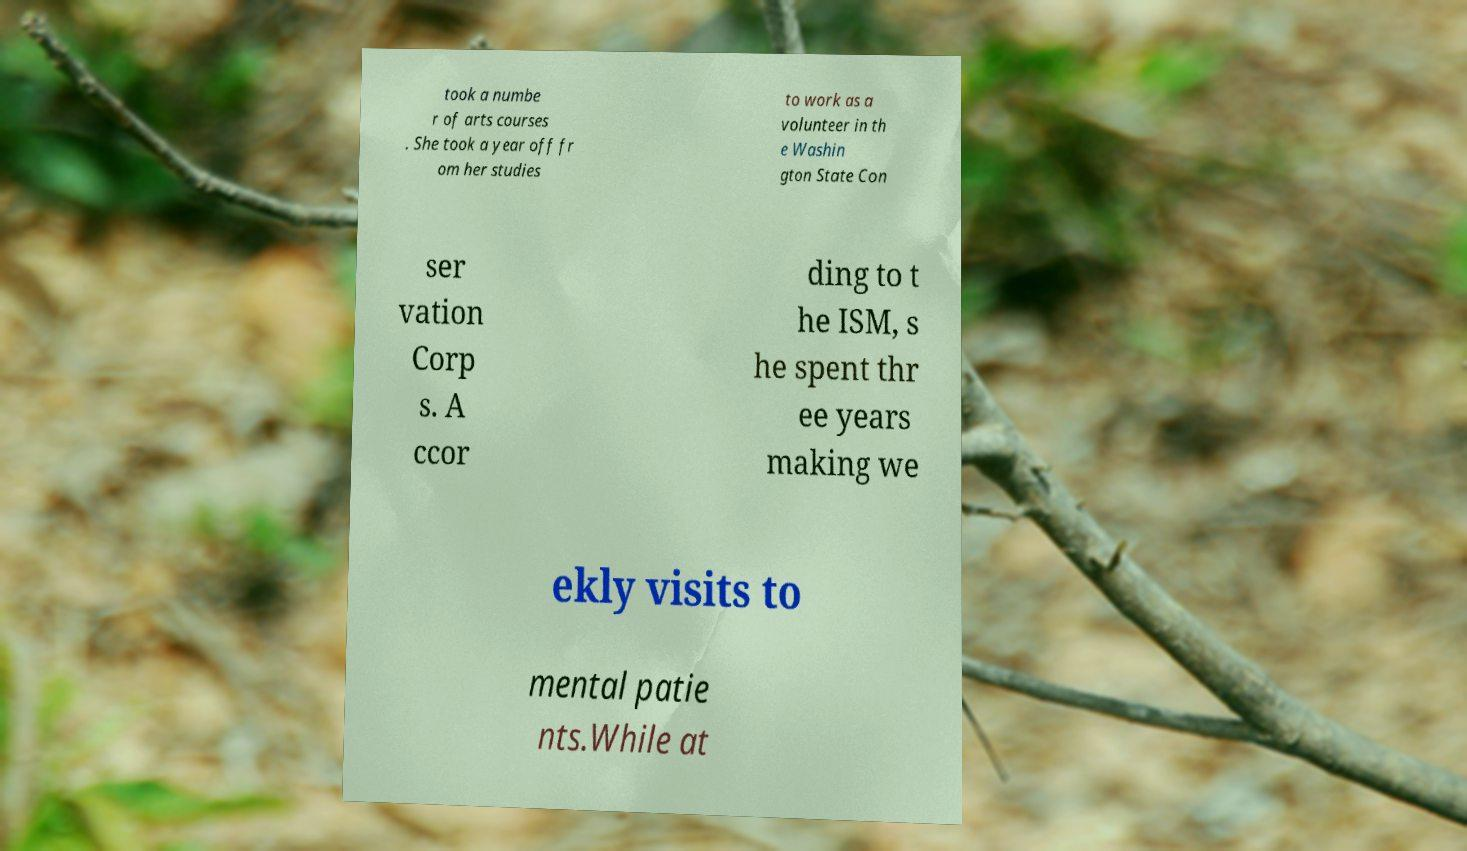For documentation purposes, I need the text within this image transcribed. Could you provide that? took a numbe r of arts courses . She took a year off fr om her studies to work as a volunteer in th e Washin gton State Con ser vation Corp s. A ccor ding to t he ISM, s he spent thr ee years making we ekly visits to mental patie nts.While at 